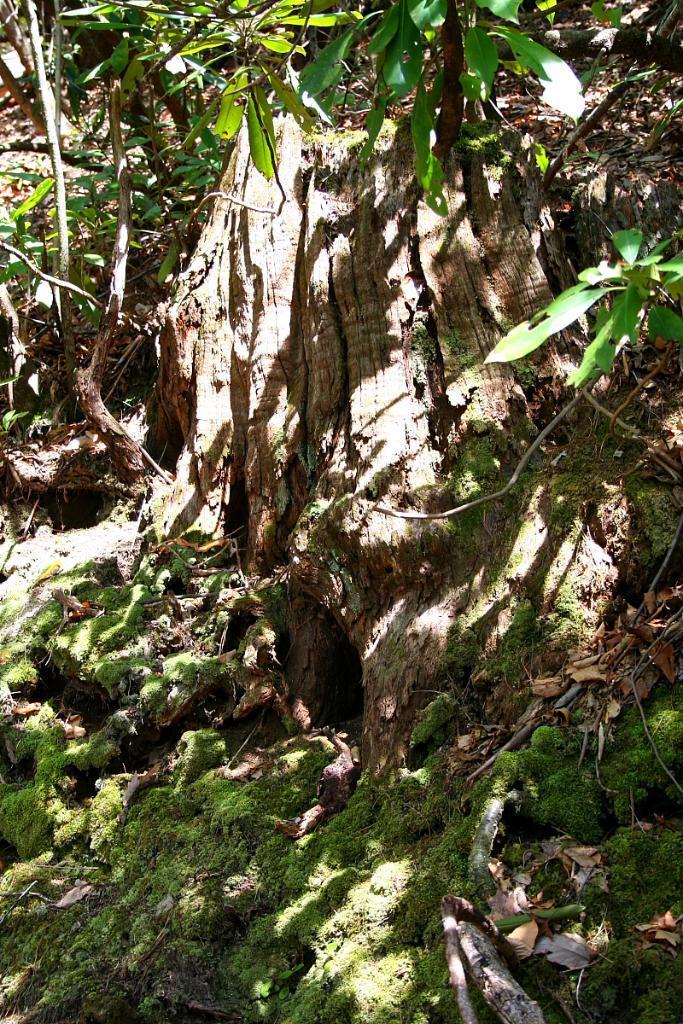In one or two sentences, can you explain what this image depicts? Here we can see grass, branch and green leaves. 